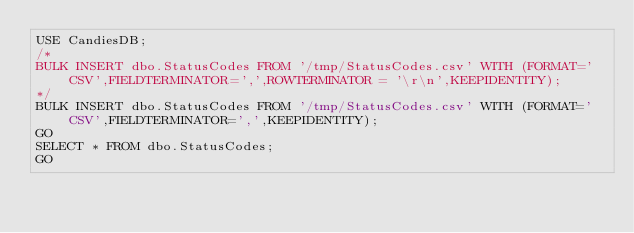Convert code to text. <code><loc_0><loc_0><loc_500><loc_500><_SQL_>USE CandiesDB;
/*
BULK INSERT dbo.StatusCodes FROM '/tmp/StatusCodes.csv' WITH (FORMAT='CSV',FIELDTERMINATOR=',',ROWTERMINATOR = '\r\n',KEEPIDENTITY);
*/
BULK INSERT dbo.StatusCodes FROM '/tmp/StatusCodes.csv' WITH (FORMAT='CSV',FIELDTERMINATOR=',',KEEPIDENTITY);
GO
SELECT * FROM dbo.StatusCodes;
GO</code> 